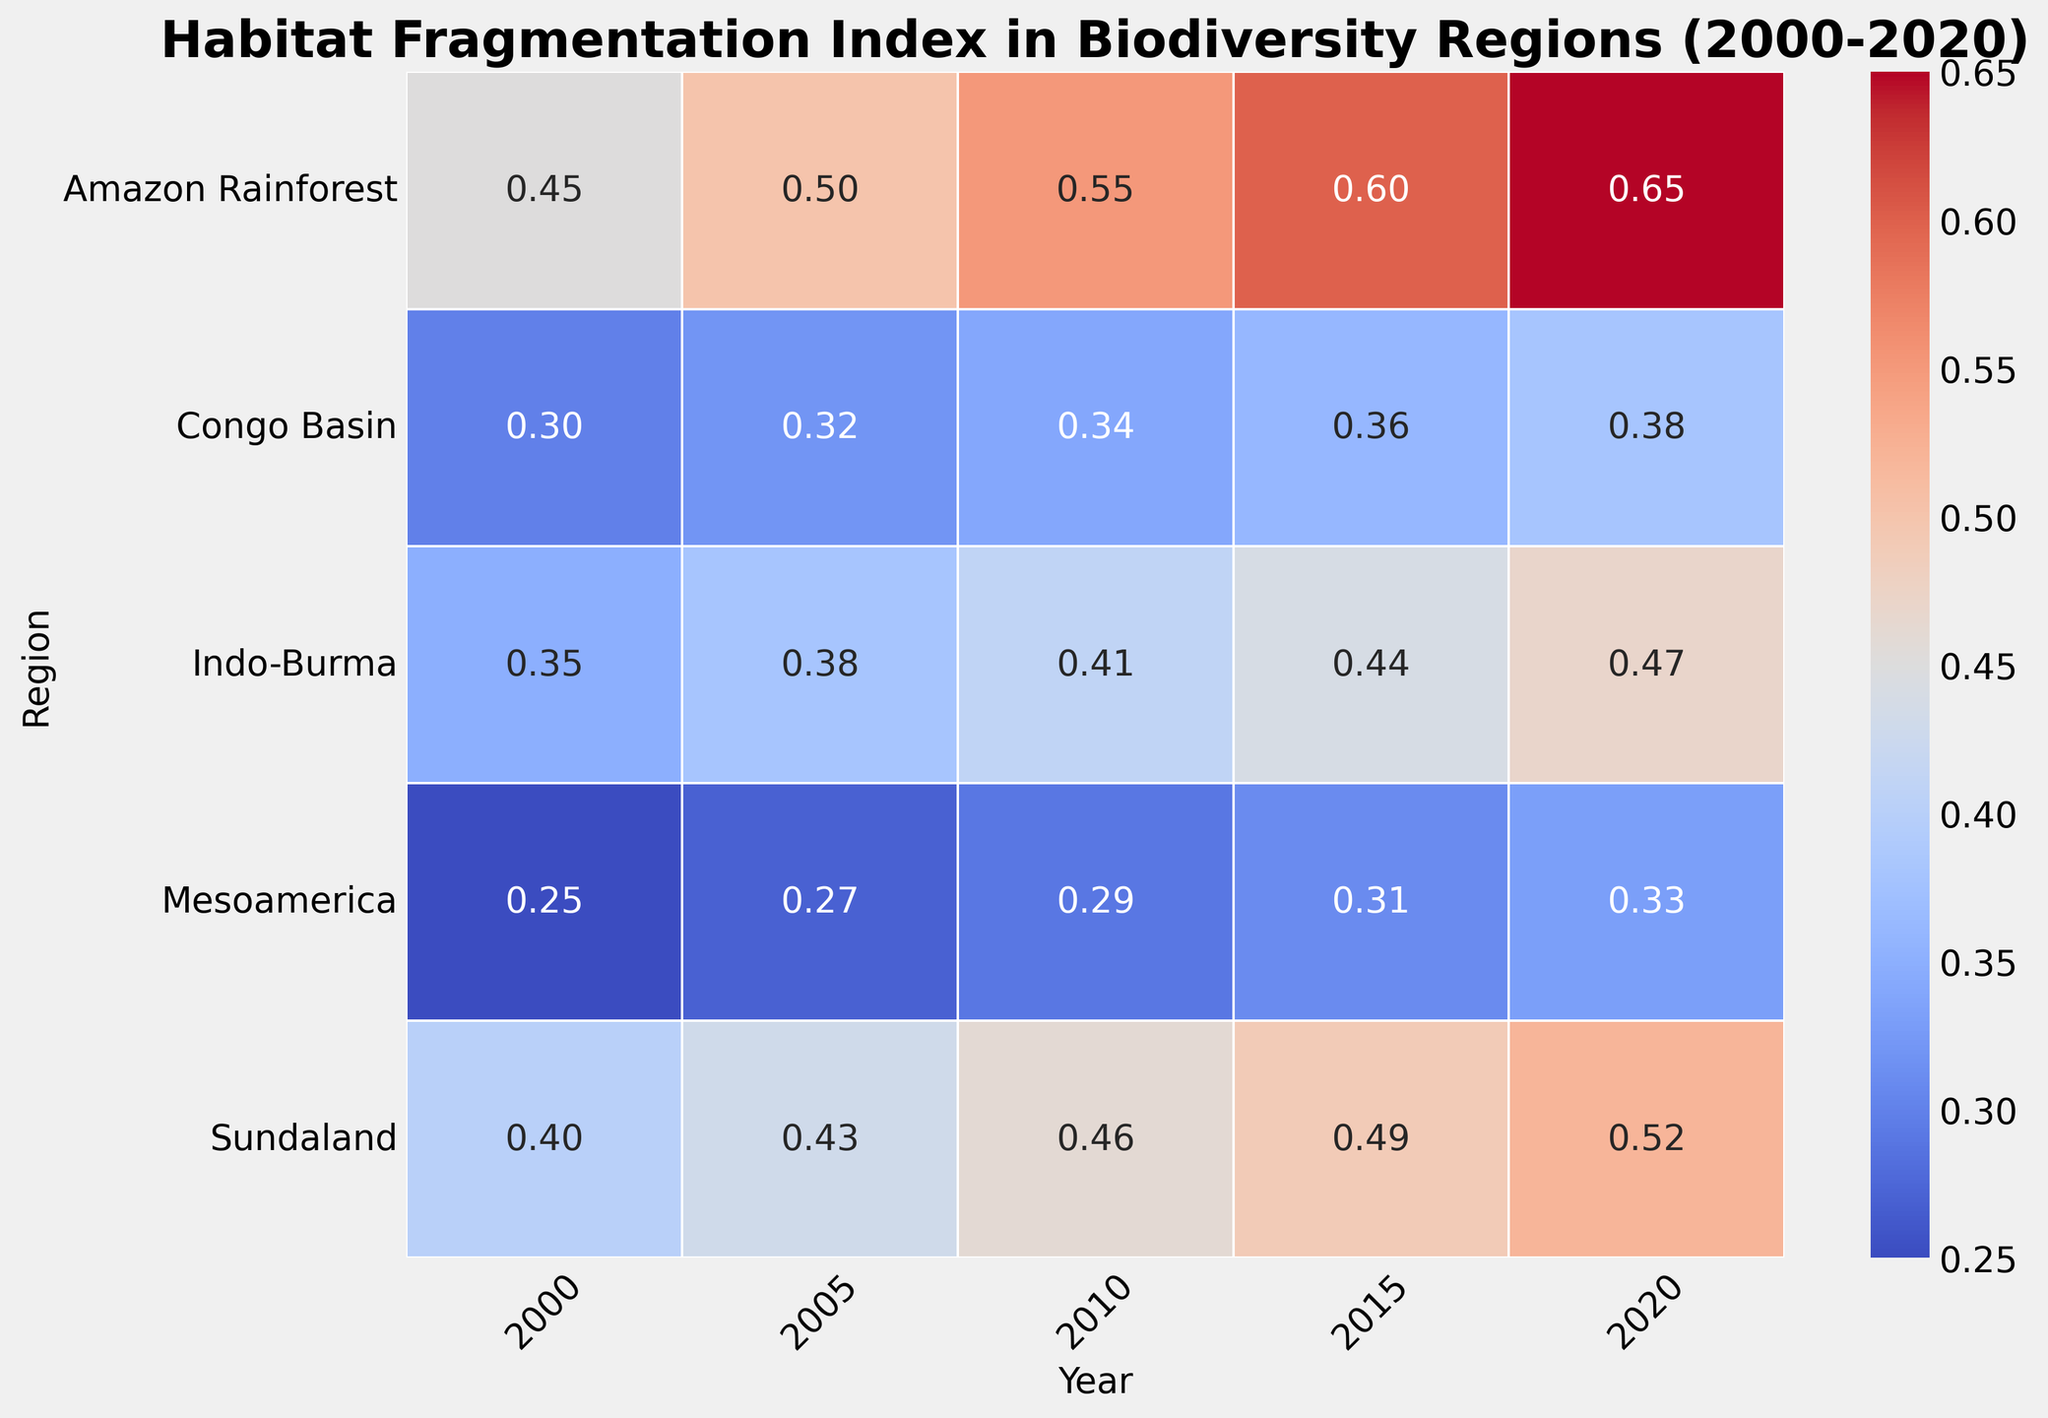Which region had the highest increase in the Fragmentation Index from 2000 to 2020? First, identify the Fragmentation Index values for each region in 2000 and 2020. Then, calculate the difference for each region and determine which one had the highest increase. In the Amazon Rainforest, it increased from 0.45 to 0.65, an increase of 0.20. Congo Basin increased from 0.30 to 0.38, an increase of 0.08. Sundaland increased from 0.40 to 0.52, an increase of 0.12. Mesoamerica increased from 0.25 to 0.33, an increase of 0.08. Indo-Burma increased from 0.35 to 0.47, an increase of 0.12. Among these, the Amazon Rainforest had the highest increase.
Answer: Amazon Rainforest What was the Fragmentation Index in Sundaland in 2015? Look at the intersection of the "Sundaland" row and the "2015" column in the heatmap, which shows a Fragmentation Index of 0.49.
Answer: 0.49 Which region had the lowest Fragmentation Index in 2020? Compare the Fragmentation Index values across all regions for the year 2020. The lowest value is for Mesoamerica with 0.33.
Answer: Mesoamerica How does the Fragmentation Index in the Congo Basin compare between 2005 and 2010? Look at the values for the Congo Basin in 2005 (0.32) and 2010 (0.34). Calculate the difference: 0.34 - 0.32 = 0.02. The index increased by 0.02 over these years.
Answer: Increased by 0.02 Which two regions had exactly equal Fragmentation Index values in any given year? Inspect the heatmap to find regions with the same Fragmentation Index in a particular year. Indigo-Burma and Sundaland both had a Fragmentation Index of 0.46 in 2010.
Answer: Indo-Burma and Sundaland What is the average Fragmentation Index for the Amazon Rainforest over the 20-year period? Add the Fragmentation Index values from 2000 to 2020 for the Amazon Rainforest (0.45 + 0.50 + 0.55 + 0.60 + 0.65 = 2.75). Then divide by the number of years (5): 2.75 / 5 = 0.55.
Answer: 0.55 Between 2000 and 2010, which region had the smallest change in its Fragmentation Index? Compute the absolute change in the Fragmentation Index for each region over the decade. Amazon Rainforest: 0.55 - 0.45 = 0.10, Congo Basin: 0.34 - 0.30 = 0.04, Sundaland: 0.46 - 0.40 = 0.06, Mesoamerica: 0.29 - 0.25 = 0.04, Indo-Burma: 0.41 - 0.35 = 0.06. Both the Congo Basin and Mesoamerica have the least change of 0.04.
Answer: Congo Basin and Mesoamerica In which year did Mesoamerica have its highest Fragmentation Index? Identify the highest value for Mesoamerica across the years. The highest Fragmentation Index for Mesoamerica is 0.33 in 2020.
Answer: 2020 In 2005, which region had a higher Fragmentation Index: Sundaland or Indo-Burma? Compare the indices for Sundaland (0.43) and Indo-Burma (0.38) in 2005. Sundaland has the higher value.
Answer: Sundaland What was the Fragmentation Index trend in Indo-Burma from 2000 to 2020? Examine the values for Indo-Burma from 2000 to 2020: 0.35 (2000), 0.38 (2005), 0.41 (2010), 0.44 (2015), 0.47 (2020). The trend shows a consistent increase over time.
Answer: Increasing 